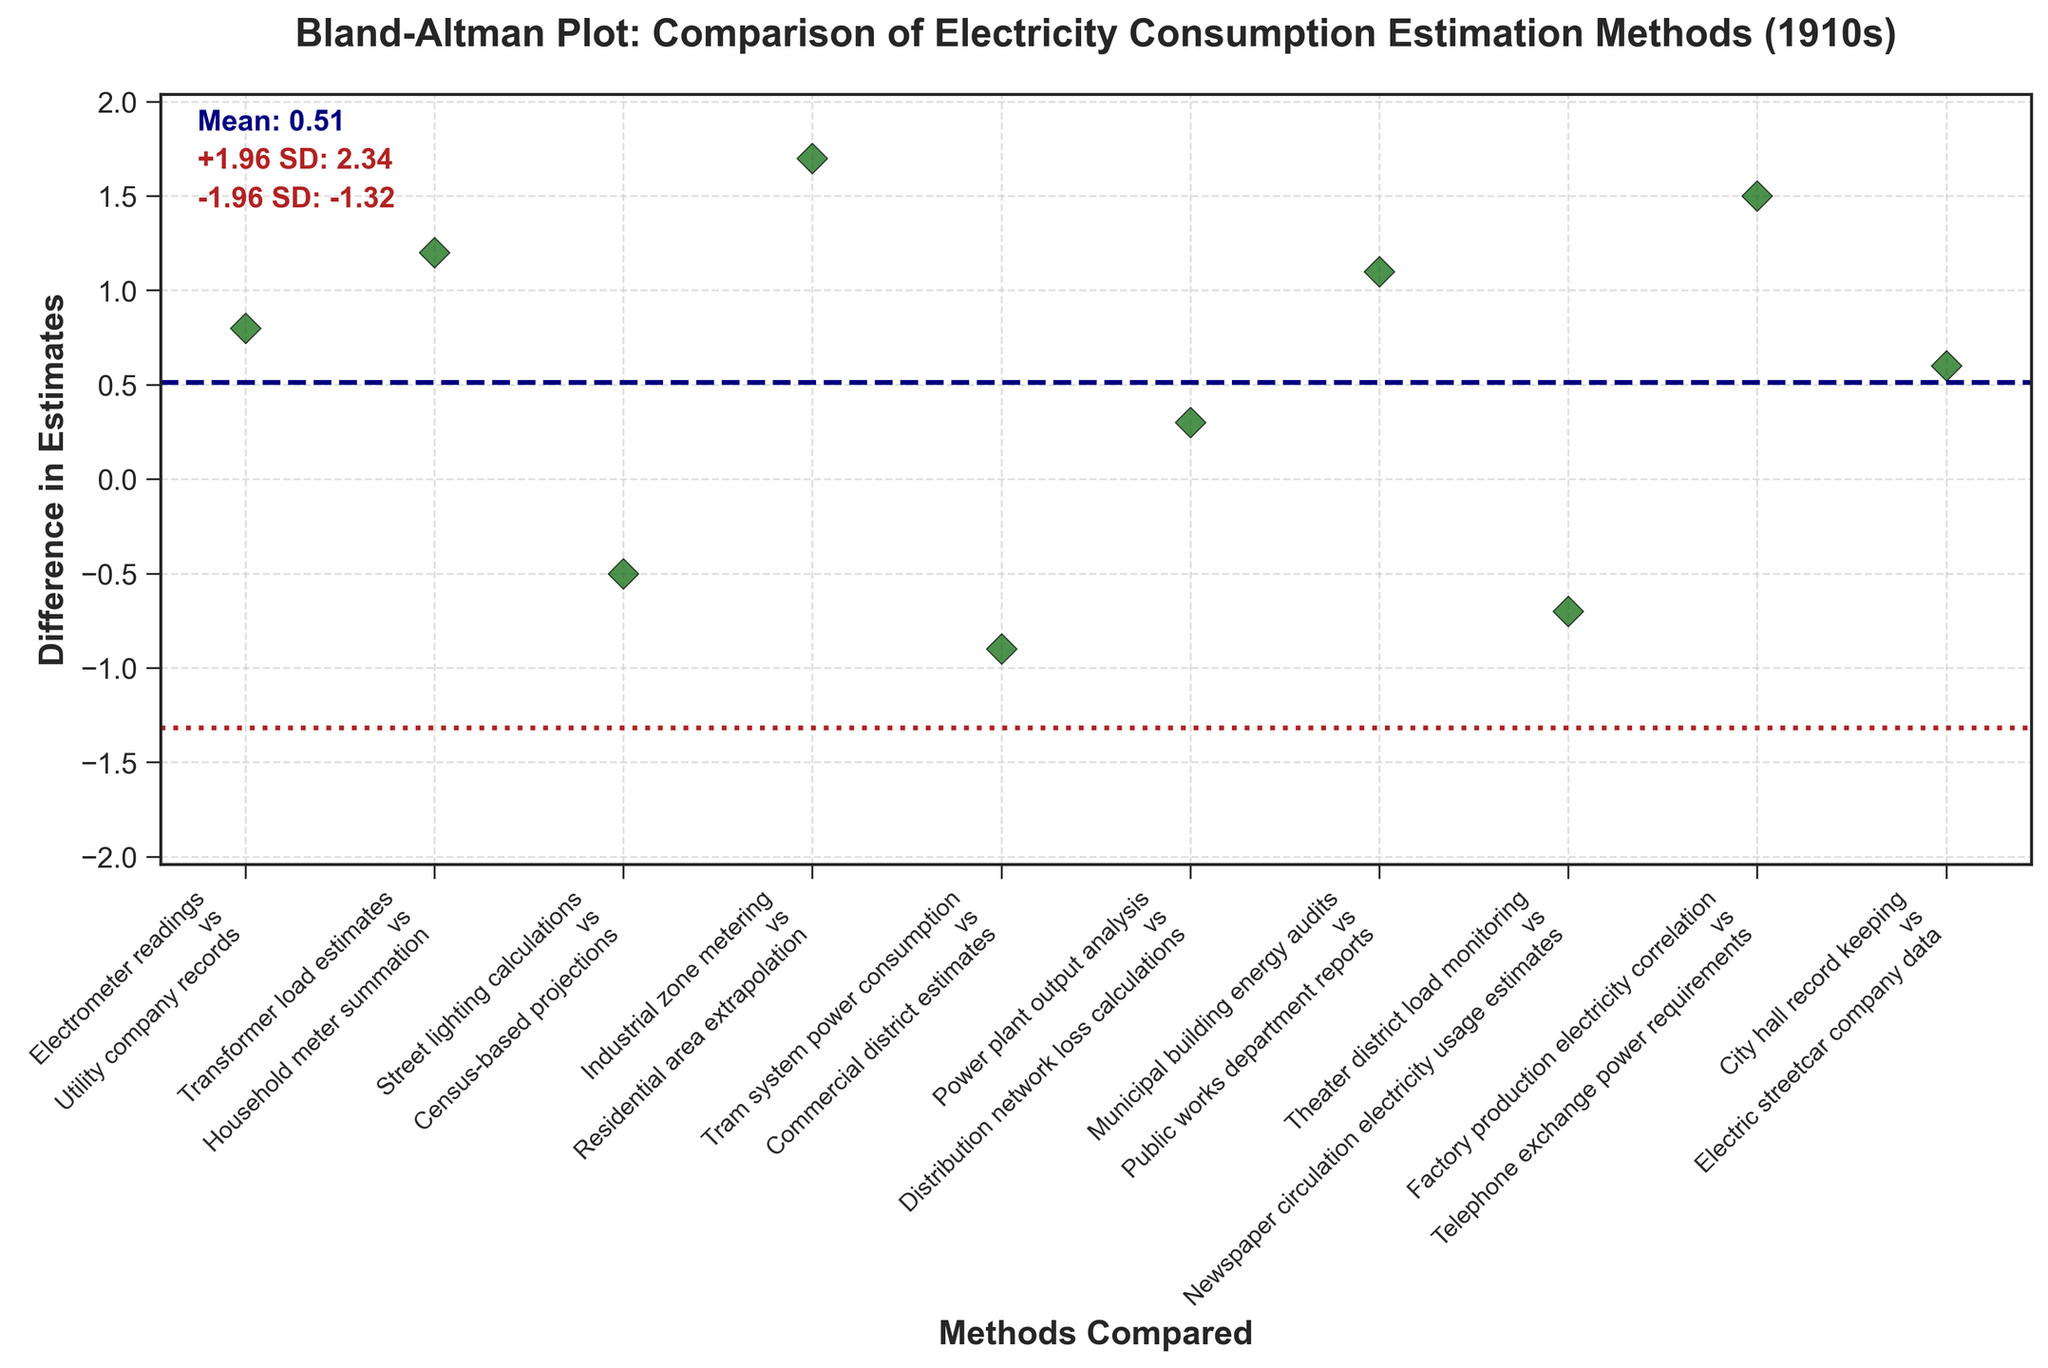What is the mean difference in estimates between the methods? The mean difference is marked by a navy dashed line. By looking at the annotations, we see the mean is 0.81
Answer: 0.81 How many method comparisons fall below the mean difference line? Check which data points are below the navy dashed line (mean difference). There are three points below it: Street lighting calculations vs Census-based projections, Tram system power consumption vs Commercial district estimates, and Theater district load monitoring vs Newspaper circulation electricity usage estimates.
Answer: 3 Which method comparison has the highest difference in estimates? Check which data point is the farthest above the navy dashed line. It's Industrial zone metering vs Residential area extrapolation.
Answer: Industrial zone metering vs Residential area extrapolation What are the upper and lower 1.96 standard deviation limits? The red dotted lines represent 1.96 standard deviations above and below the mean. According to the annotations, they are at 3.04 (upper) and -1.42 (lower).
Answer: 3.04 and -1.42 How many method comparisons fall outside the limits of agreement? Check which data points lie outside the red dotted lines. There are no points outside these limits.
Answer: 0 What does the point labeled "Theater district load monitoring vs Newspaper circulation electricity usage estimates" indicate? This point is below the navy dashed line and above the lower red-dotted line, meaning it has a negative difference in estimates of around -0.7 units but within the defined agreement limits.
Answer: Negative difference, within limits 